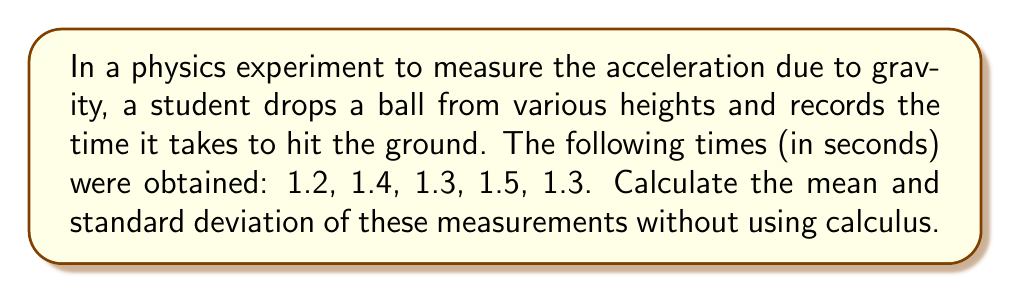Solve this math problem. 1. Calculate the mean:
   The mean $\bar{x}$ is the sum of all values divided by the number of values.
   
   $\bar{x} = \frac{\sum_{i=1}^{n} x_i}{n}$
   
   $\bar{x} = \frac{1.2 + 1.4 + 1.3 + 1.5 + 1.3}{5} = \frac{6.7}{5} = 1.34$ seconds

2. Calculate the standard deviation:
   The standard deviation $s$ is the square root of the average of the squared differences from the mean.
   
   $s = \sqrt{\frac{\sum_{i=1}^{n} (x_i - \bar{x})^2}{n - 1}}$

   a. Calculate the differences from the mean:
      1.2 - 1.34 = -0.14
      1.4 - 1.34 = 0.06
      1.3 - 1.34 = -0.04
      1.5 - 1.34 = 0.16
      1.3 - 1.34 = -0.04

   b. Square these differences:
      (-0.14)² = 0.0196
      (0.06)² = 0.0036
      (-0.04)² = 0.0016
      (0.16)² = 0.0256
      (-0.04)² = 0.0016

   c. Sum the squared differences:
      0.0196 + 0.0036 + 0.0016 + 0.0256 + 0.0016 = 0.052

   d. Divide by (n-1) = 4 and take the square root:
      $s = \sqrt{\frac{0.052}{4}} = \sqrt{0.013} \approx 0.114$ seconds
Answer: Mean: 1.34 s, Standard Deviation: 0.114 s 